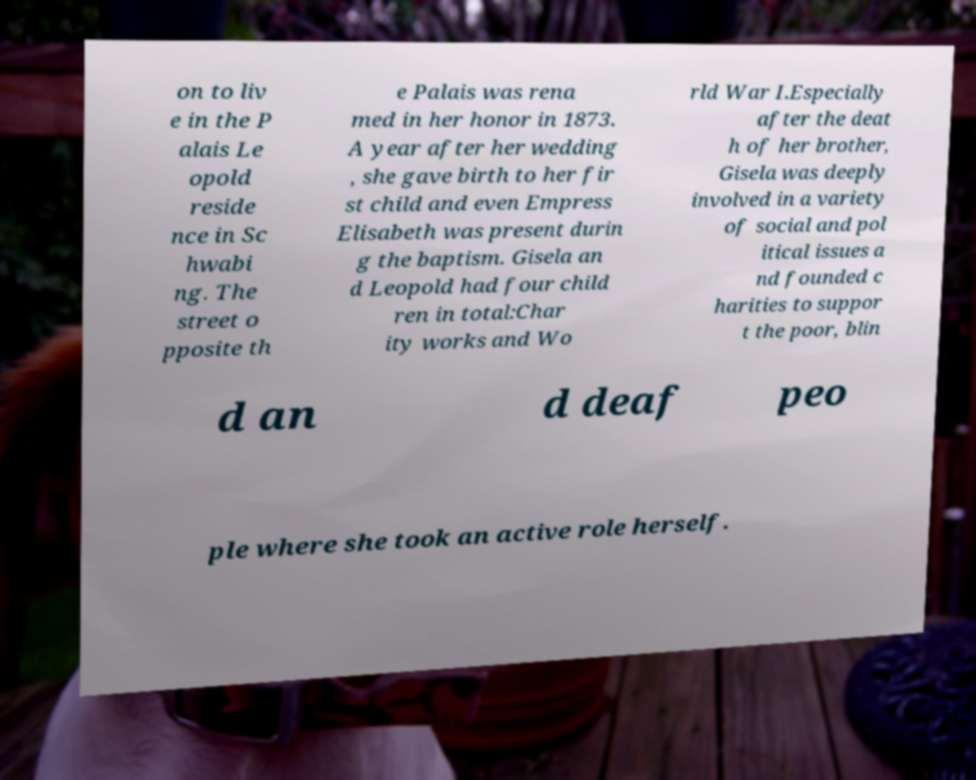There's text embedded in this image that I need extracted. Can you transcribe it verbatim? on to liv e in the P alais Le opold reside nce in Sc hwabi ng. The street o pposite th e Palais was rena med in her honor in 1873. A year after her wedding , she gave birth to her fir st child and even Empress Elisabeth was present durin g the baptism. Gisela an d Leopold had four child ren in total:Char ity works and Wo rld War I.Especially after the deat h of her brother, Gisela was deeply involved in a variety of social and pol itical issues a nd founded c harities to suppor t the poor, blin d an d deaf peo ple where she took an active role herself. 